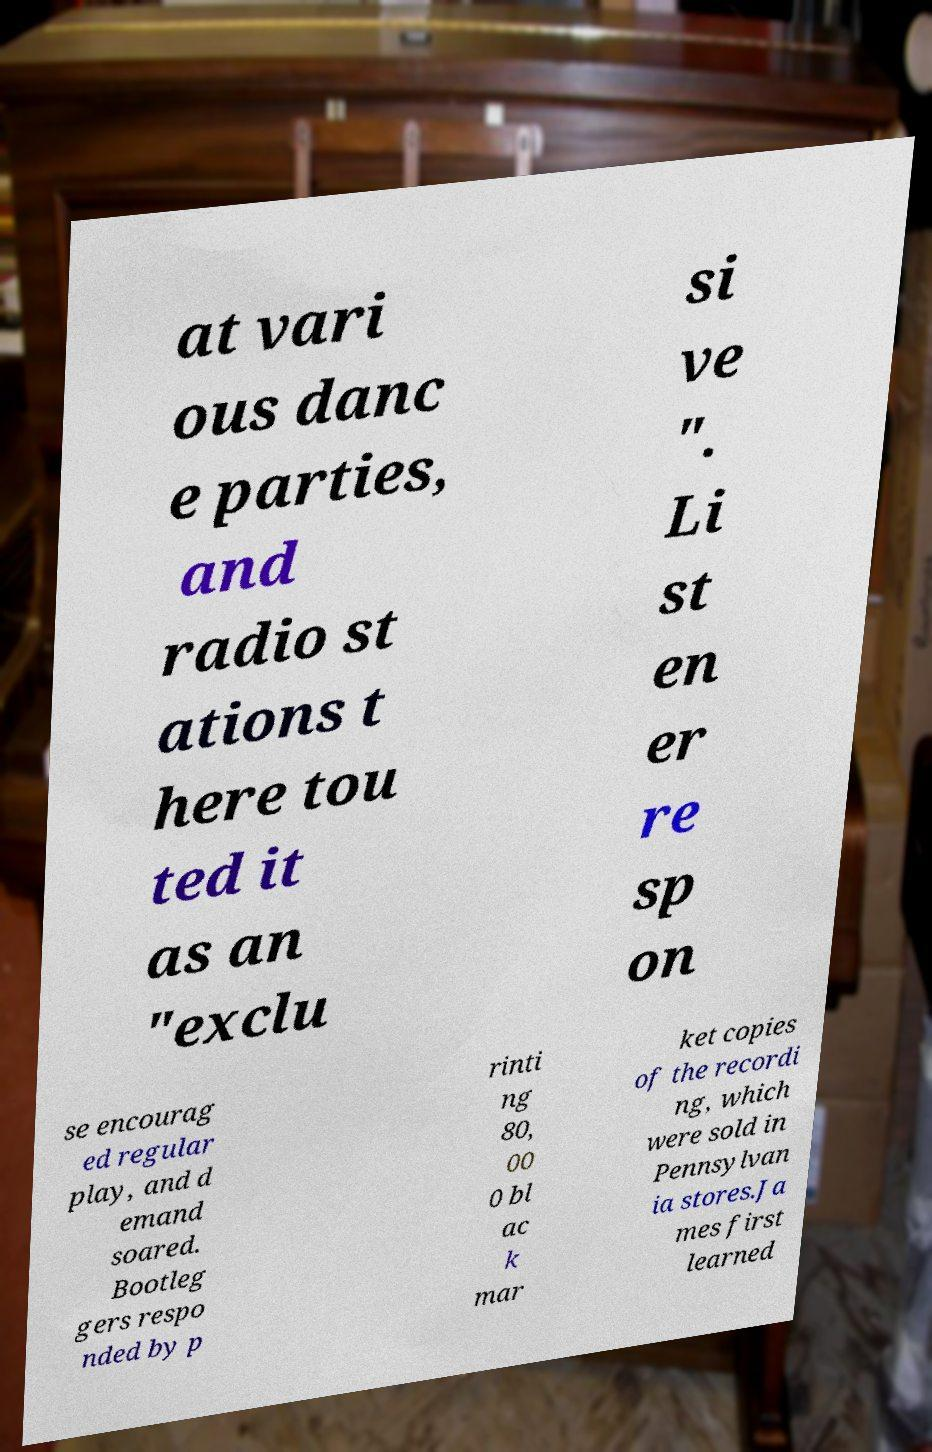I need the written content from this picture converted into text. Can you do that? at vari ous danc e parties, and radio st ations t here tou ted it as an "exclu si ve ". Li st en er re sp on se encourag ed regular play, and d emand soared. Bootleg gers respo nded by p rinti ng 80, 00 0 bl ac k mar ket copies of the recordi ng, which were sold in Pennsylvan ia stores.Ja mes first learned 